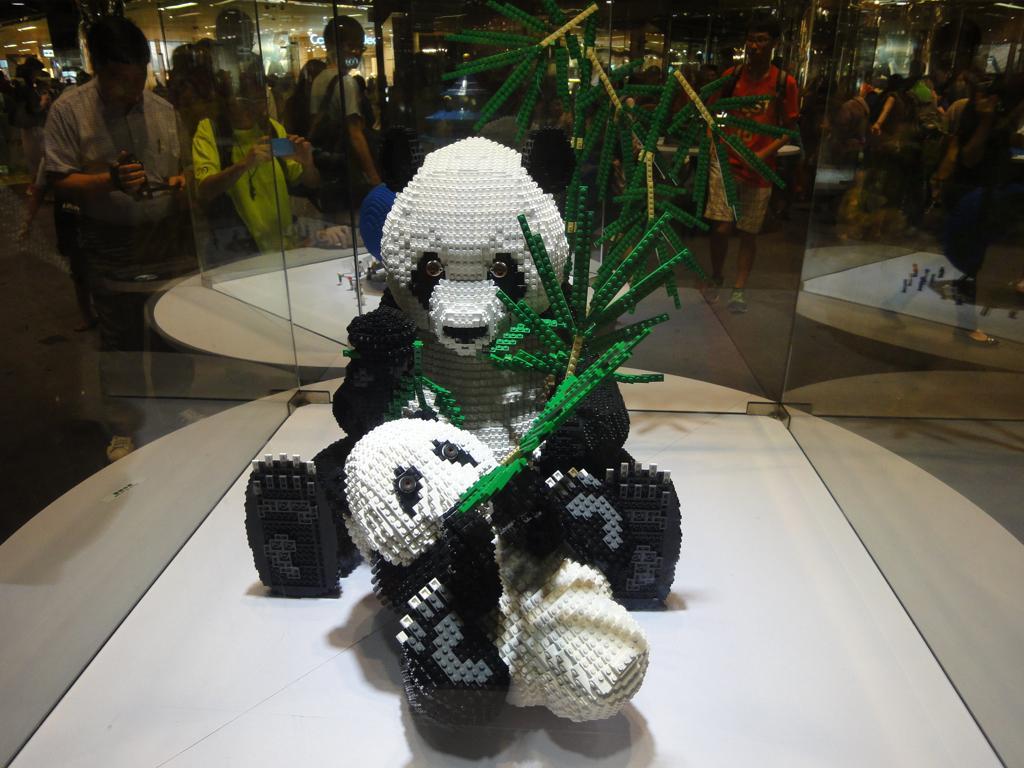Could you give a brief overview of what you see in this image? There is a depiction of a panda as we can see in the middle of this image. We can see people standing in the background. 